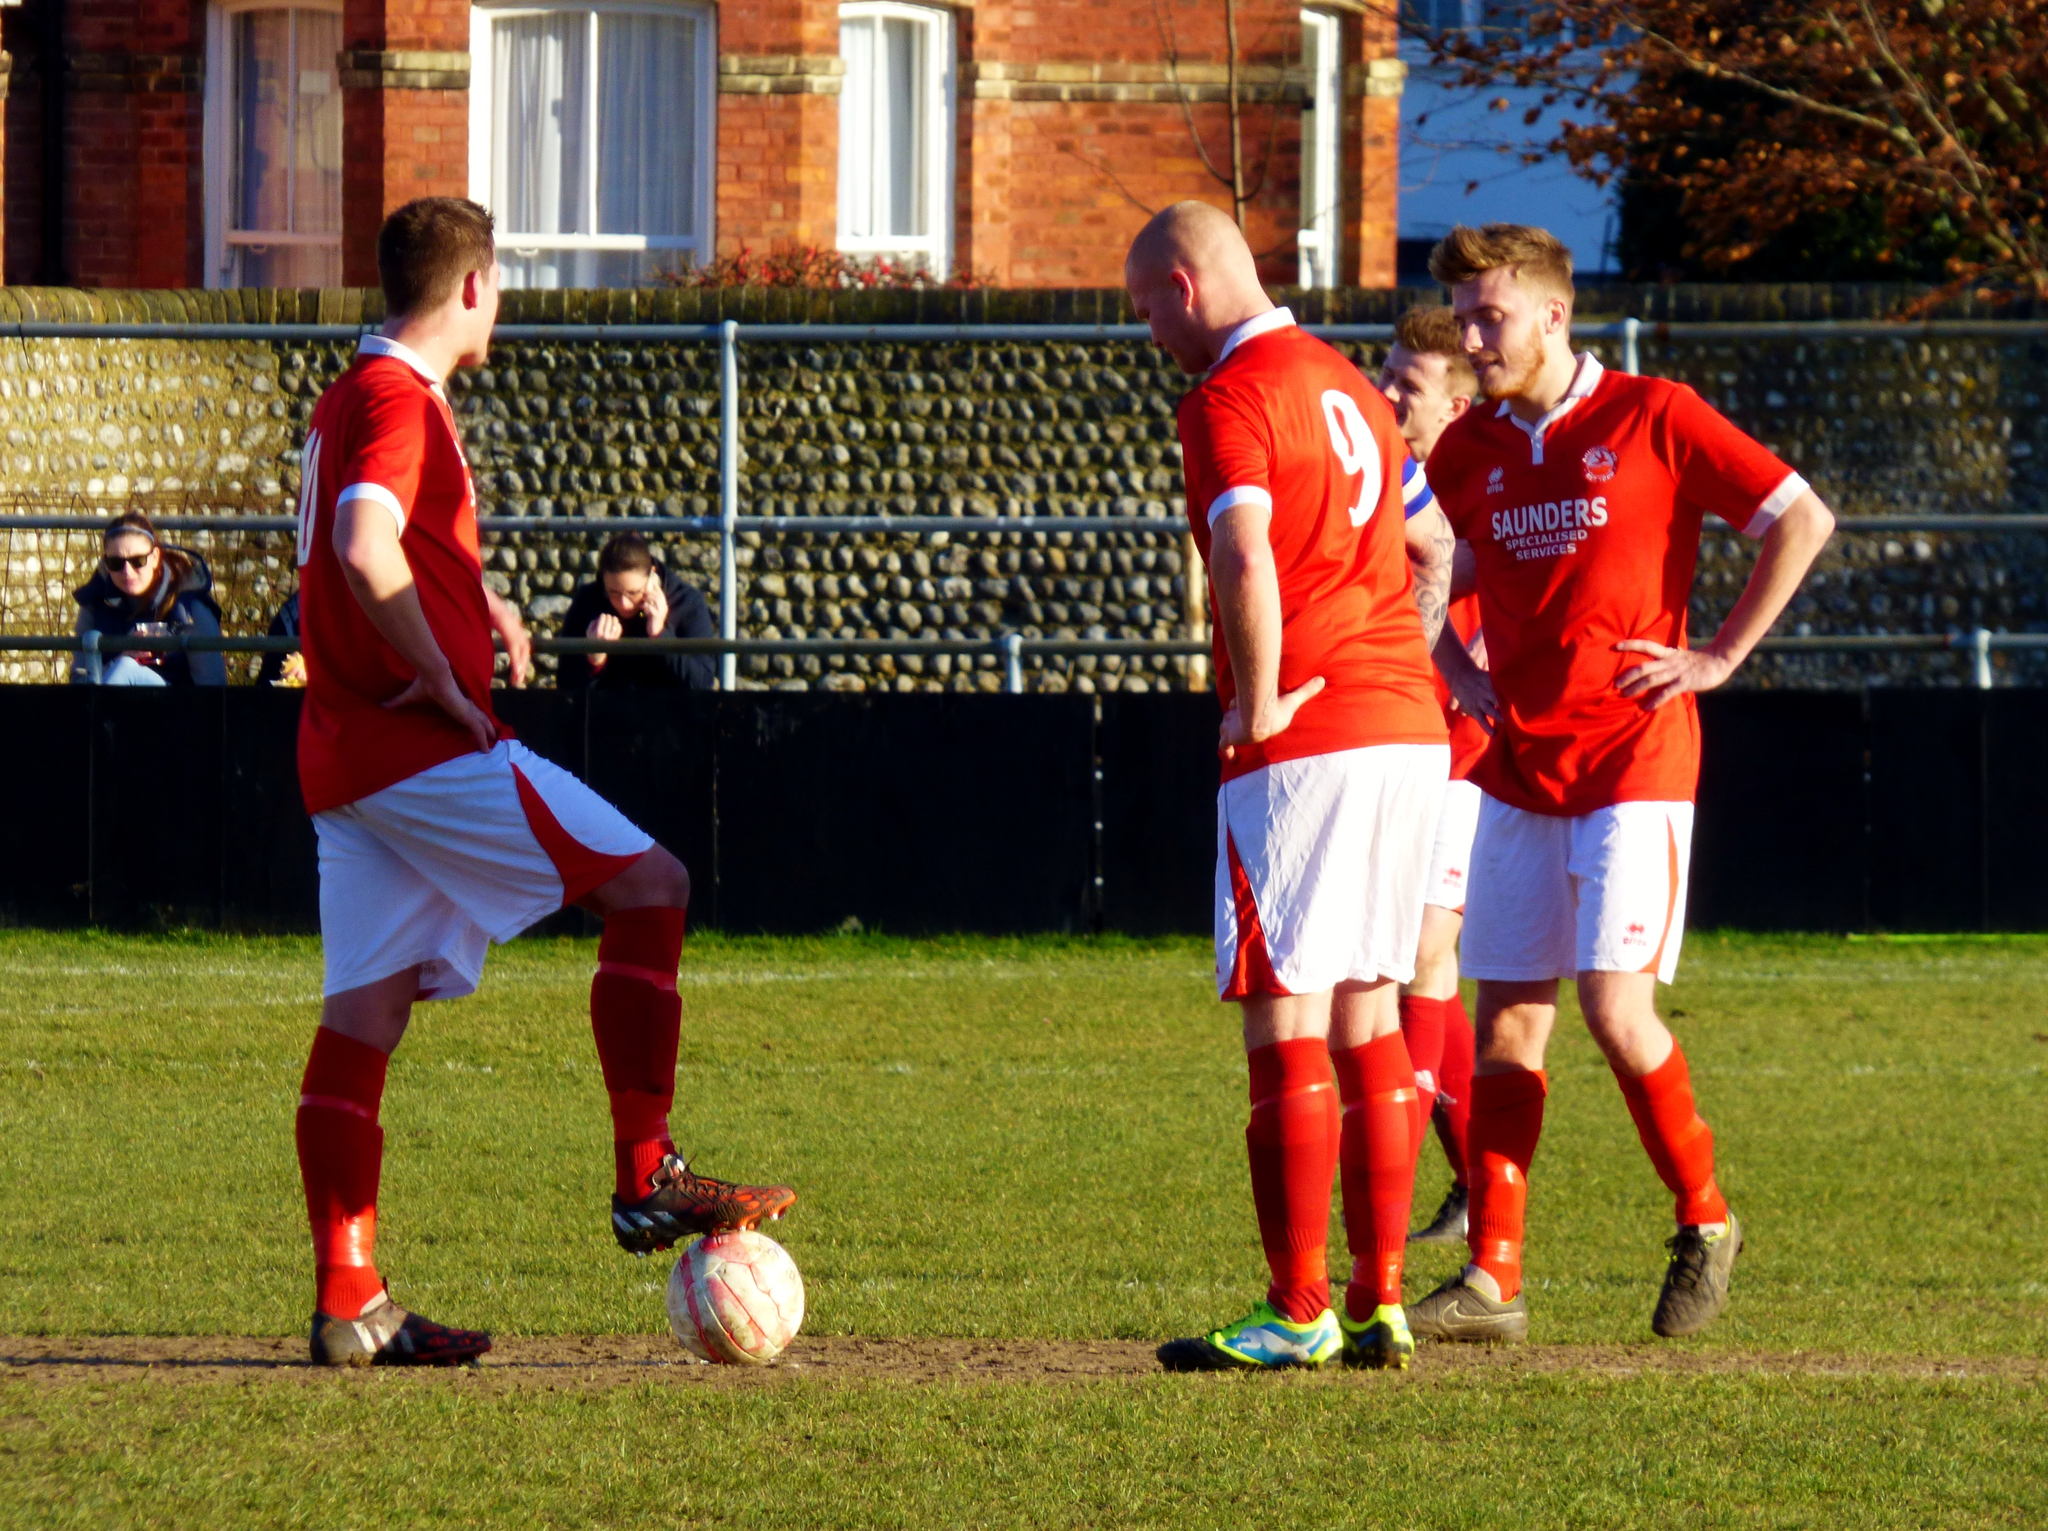<image>
Describe the image concisely. Ball players in red jerseys from Saunders Specialized Services. 